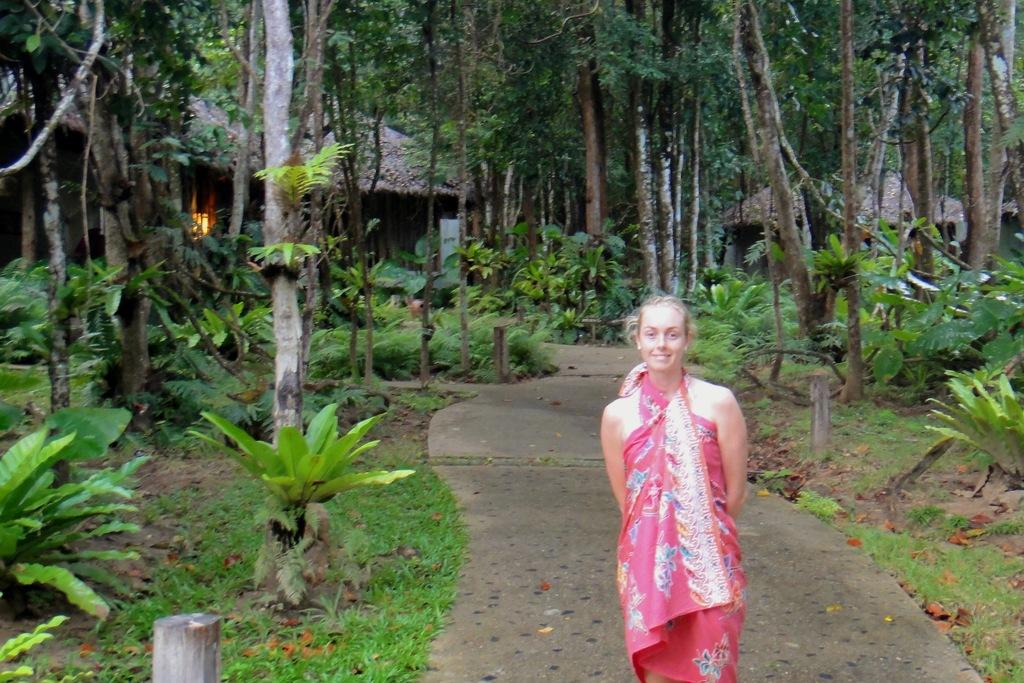What is the main subject of the image? The main subject of the image is a girl standing on the road. Where is the girl located in the image? The girl is at the bottom of the image. What can be seen in the background of the image? There are trees in the background of the image. Where is the faucet located in the image? There is no faucet present in the image. What type of nail is the girl holding in the image? There is no nail present in the image; the girl is simply standing on the road. 